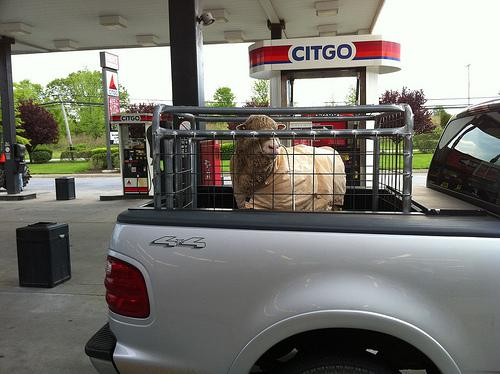Question: what is in the back of the truck?
Choices:
A. Cows.
B. Sheep.
C. Chickens.
D. Bales of hay.
Answer with the letter. Answer: B Question: how many gas pumps are shown in the picture?
Choices:
A. Three.
B. Five.
C. Six.
D. Two.
Answer with the letter. Answer: D Question: what side of the picture are the trash cans located?
Choices:
A. Right.
B. Left.
C. Top.
D. Bottom.
Answer with the letter. Answer: B Question: where is this picture taken?
Choices:
A. New York City.
B. Chicago.
C. CITGO.
D. By the Niagara Falls.
Answer with the letter. Answer: C Question: what direction is the truck facing?
Choices:
A. Left.
B. Right.
C. Towards the building.
D. Away from the mailbox.
Answer with the letter. Answer: B Question: what type of truck is this?
Choices:
A. 6-wheeler.
B. A delivery truck.
C. An ice cream truck.
D. 4x4.
Answer with the letter. Answer: D Question: what color is the truck?
Choices:
A. White.
B. Red.
C. Silver.
D. Green.
Answer with the letter. Answer: A Question: what is the color of the blanket on the sheep?
Choices:
A. Red.
B. Yellow.
C. Blue.
D. Pink.
Answer with the letter. Answer: B 